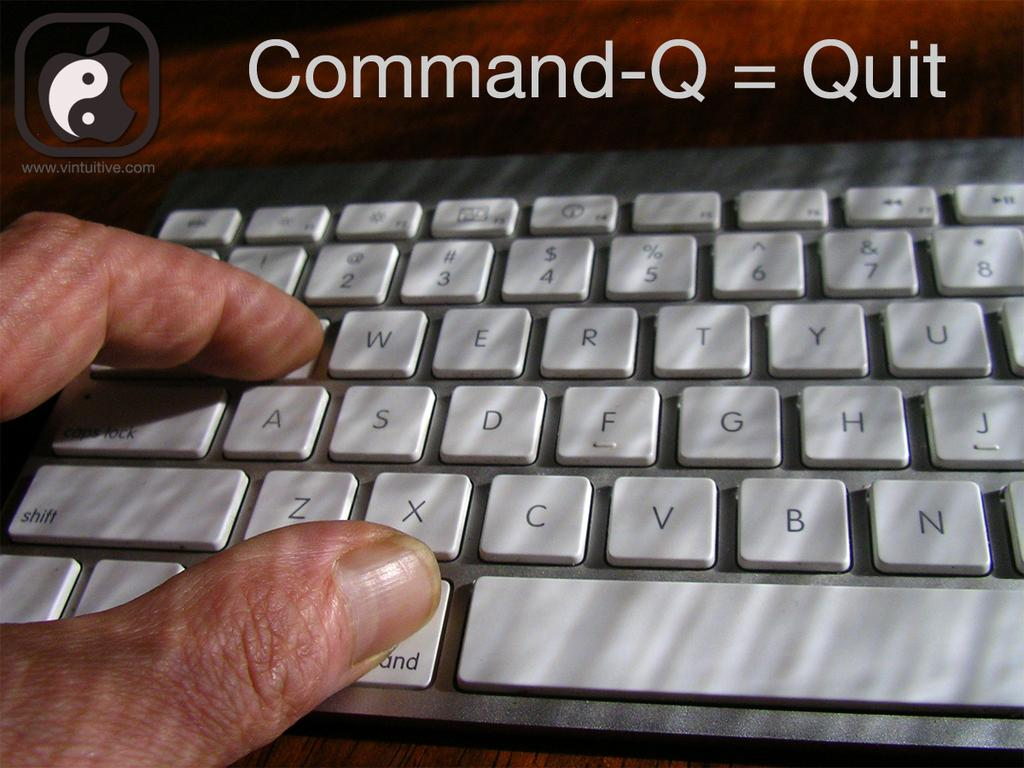<image>
Give a short and clear explanation of the subsequent image. An apple keyboard is shown with instructions of how to use the quit function. 